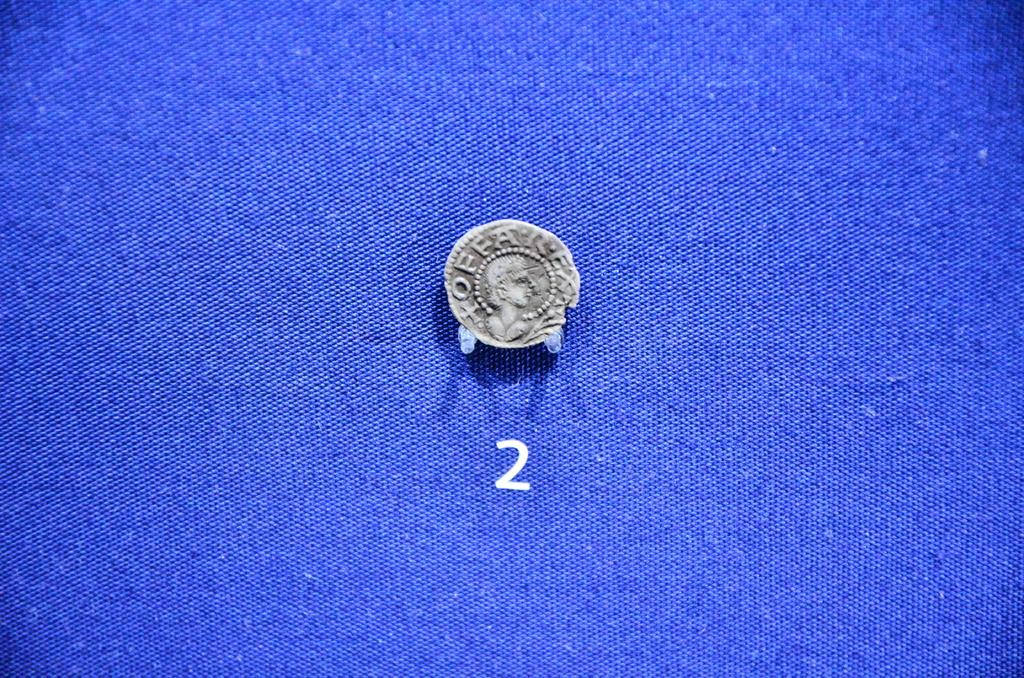<image>
Render a clear and concise summary of the photo. The coin is number 2 on the blue table. 